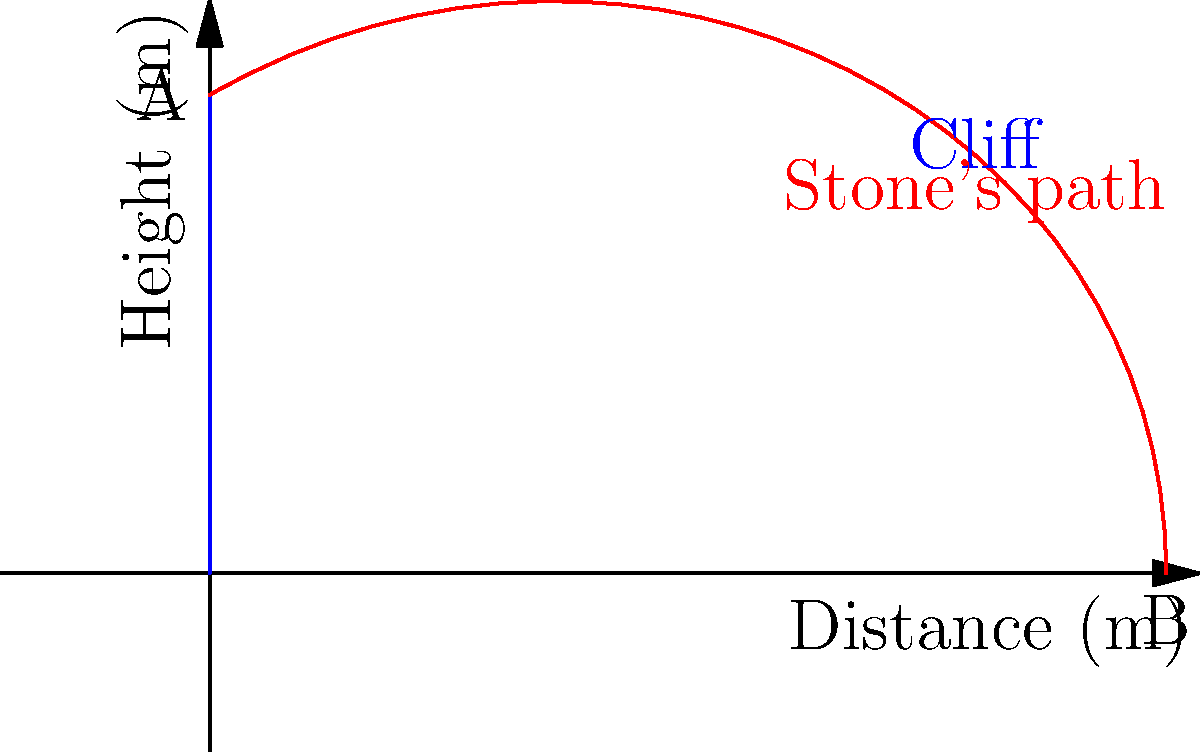As you stand atop Whispering Cliff, a favorite spot for sharing local legends, you decide to demonstrate the flight of the mythical "Singing Stone" by throwing a regular stone. If you throw the stone horizontally from a height of 50 meters with an initial velocity of 20 m/s, how far from the base of the cliff will the stone land? Assume no air resistance and use $g = 9.8$ m/s². Let's approach this step-by-step:

1) This is a projectile motion problem. The stone's motion can be split into horizontal and vertical components.

2) Horizontally, the stone moves at a constant velocity (no acceleration):
   $x = v_0t$, where $v_0 = 20$ m/s and $x$ is the horizontal distance.

3) Vertically, the stone accelerates due to gravity:
   $y = y_0 - \frac{1}{2}gt^2$, where $y_0 = 50$ m and $g = 9.8$ m/s².

4) The stone hits the ground when $y = 0$. So we can find the time of flight:
   $0 = 50 - \frac{1}{2}(9.8)t^2$
   $25 = 4.9t^2$
   $t^2 = 5.1$
   $t = \sqrt{5.1} \approx 2.26$ seconds

5) Now we can use this time in the horizontal equation to find the distance:
   $x = 20 * 2.26 = 45.2$ meters

Therefore, the stone will land approximately 45.2 meters from the base of the cliff.
Answer: 45.2 meters 